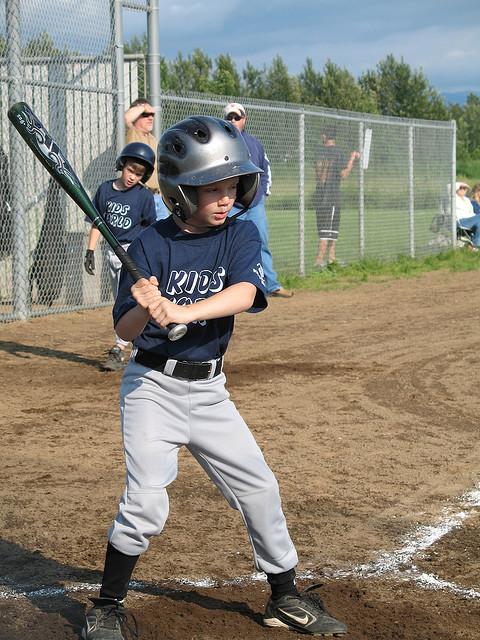What game is being played?
Quick response, please. Baseball. What color uniform is this kid wearing?
Answer briefly. Blue and gray. What is the kid holding?
Short answer required. Bat. 